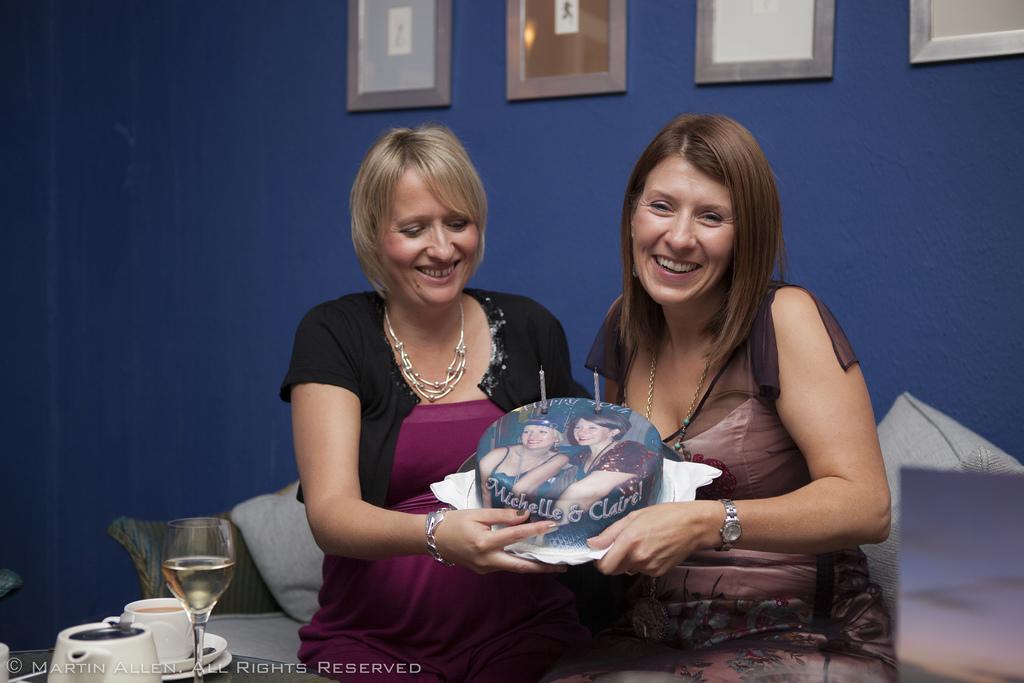How many candles are on the cake?
Give a very brief answer. 2. 